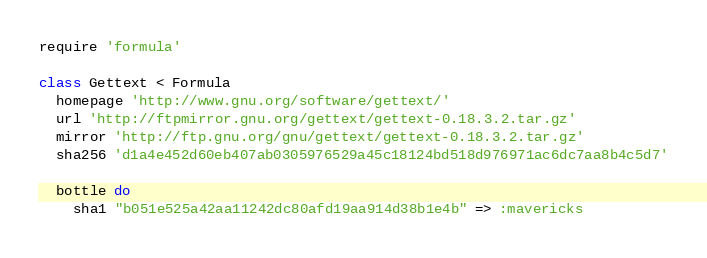Convert code to text. <code><loc_0><loc_0><loc_500><loc_500><_Ruby_>require 'formula'

class Gettext < Formula
  homepage 'http://www.gnu.org/software/gettext/'
  url 'http://ftpmirror.gnu.org/gettext/gettext-0.18.3.2.tar.gz'
  mirror 'http://ftp.gnu.org/gnu/gettext/gettext-0.18.3.2.tar.gz'
  sha256 'd1a4e452d60eb407ab0305976529a45c18124bd518d976971ac6dc7aa8b4c5d7'

  bottle do
    sha1 "b051e525a42aa11242dc80afd19aa914d38b1e4b" => :mavericks</code> 